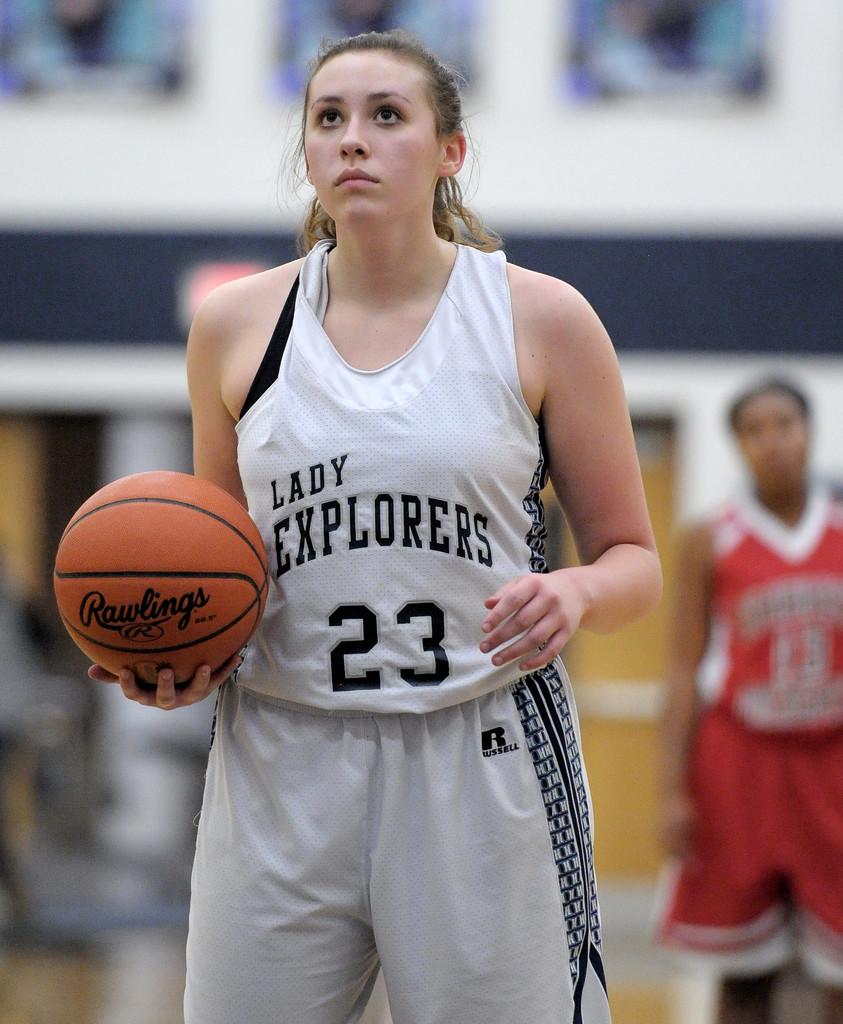Which company made the ball?
Your response must be concise. Rawlings. 